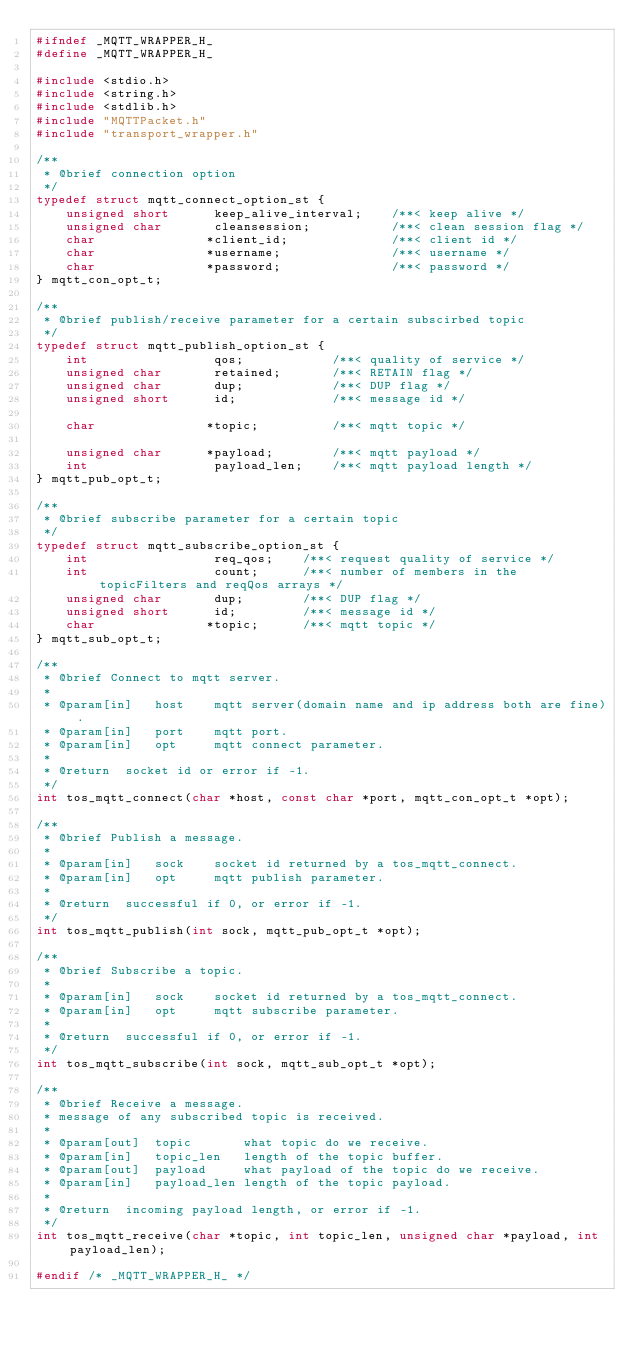<code> <loc_0><loc_0><loc_500><loc_500><_C_>#ifndef _MQTT_WRAPPER_H_
#define _MQTT_WRAPPER_H_

#include <stdio.h>
#include <string.h>
#include <stdlib.h>
#include "MQTTPacket.h"
#include "transport_wrapper.h"

/**
 * @brief connection option
 */
typedef struct mqtt_connect_option_st {
    unsigned short      keep_alive_interval;    /**< keep alive */
    unsigned char       cleansession;           /**< clean session flag */
    char               *client_id;              /**< client id */
    char               *username;               /**< username */
    char               *password;               /**< password */
} mqtt_con_opt_t;

/**
 * @brief publish/receive parameter for a certain subscirbed topic
 */
typedef struct mqtt_publish_option_st {
    int                 qos;            /**< quality of service */
    unsigned char       retained;       /**< RETAIN flag */
    unsigned char       dup;            /**< DUP flag */
    unsigned short      id;             /**< message id */

    char               *topic;          /**< mqtt topic */

    unsigned char      *payload;        /**< mqtt payload */
    int                 payload_len;    /**< mqtt payload length */
} mqtt_pub_opt_t;

/**
 * @brief subscribe parameter for a certain topic
 */
typedef struct mqtt_subscribe_option_st {
    int                 req_qos;    /**< request quality of service */
    int                 count;      /**< number of members in the topicFilters and reqQos arrays */
    unsigned char       dup;        /**< DUP flag */
    unsigned short      id;         /**< message id */
    char               *topic;      /**< mqtt topic */
} mqtt_sub_opt_t;

/**
 * @brief Connect to mqtt server.
 *
 * @param[in]   host    mqtt server(domain name and ip address both are fine).
 * @param[in]   port    mqtt port.
 * @param[in]   opt     mqtt connect parameter.
 *
 * @return  socket id or error if -1.
 */
int tos_mqtt_connect(char *host, const char *port, mqtt_con_opt_t *opt);

/**
 * @brief Publish a message.
 *
 * @param[in]   sock    socket id returned by a tos_mqtt_connect.
 * @param[in]   opt     mqtt publish parameter.
 *
 * @return  successful if 0, or error if -1.
 */
int tos_mqtt_publish(int sock, mqtt_pub_opt_t *opt);

/**
 * @brief Subscribe a topic.
 *
 * @param[in]   sock    socket id returned by a tos_mqtt_connect.
 * @param[in]   opt     mqtt subscribe parameter.
 *
 * @return  successful if 0, or error if -1.
 */
int tos_mqtt_subscribe(int sock, mqtt_sub_opt_t *opt);

/**
 * @brief Receive a message.
 * message of any subscribed topic is received.
 *
 * @param[out]  topic       what topic do we receive.
 * @param[in]   topic_len   length of the topic buffer.
 * @param[out]  payload     what payload of the topic do we receive.
 * @param[in]   payload_len length of the topic payload.
 *
 * @return  incoming payload length, or error if -1.
 */
int tos_mqtt_receive(char *topic, int topic_len, unsigned char *payload, int payload_len);

#endif /* _MQTT_WRAPPER_H_ */

</code> 